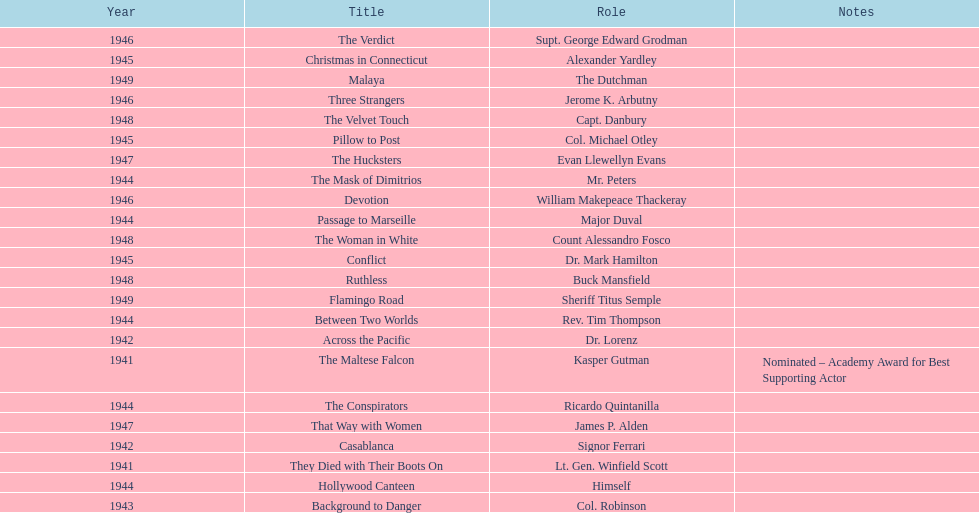What movies did greenstreet act for in 1946? Three Strangers, Devotion, The Verdict. 